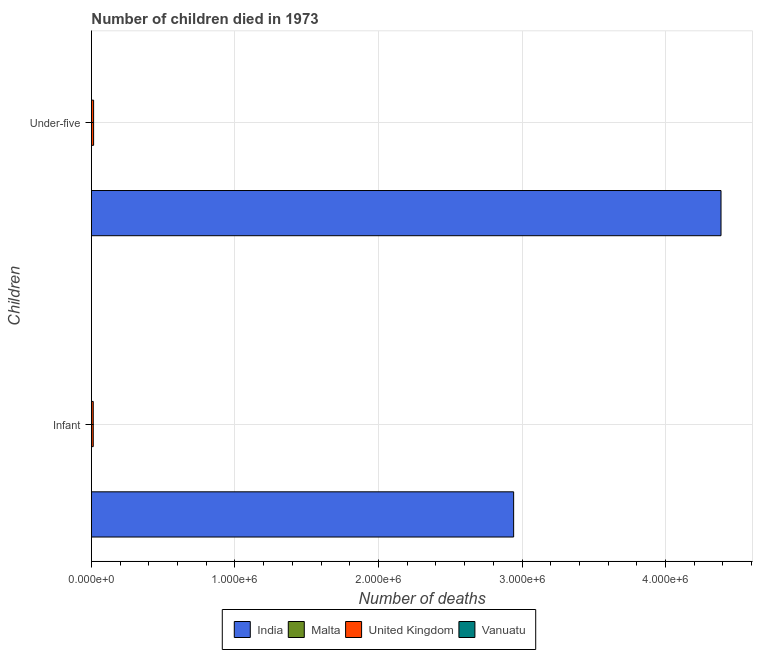How many different coloured bars are there?
Provide a succinct answer. 4. How many groups of bars are there?
Make the answer very short. 2. Are the number of bars on each tick of the Y-axis equal?
Make the answer very short. Yes. How many bars are there on the 2nd tick from the top?
Offer a very short reply. 4. How many bars are there on the 1st tick from the bottom?
Ensure brevity in your answer.  4. What is the label of the 2nd group of bars from the top?
Make the answer very short. Infant. What is the number of under-five deaths in India?
Provide a succinct answer. 4.39e+06. Across all countries, what is the maximum number of under-five deaths?
Make the answer very short. 4.39e+06. Across all countries, what is the minimum number of infant deaths?
Provide a short and direct response. 112. In which country was the number of infant deaths minimum?
Offer a terse response. Malta. What is the total number of infant deaths in the graph?
Offer a terse response. 2.95e+06. What is the difference between the number of under-five deaths in Malta and that in India?
Provide a short and direct response. -4.39e+06. What is the difference between the number of infant deaths in India and the number of under-five deaths in Malta?
Make the answer very short. 2.94e+06. What is the average number of infant deaths per country?
Your answer should be very brief. 7.39e+05. What is the difference between the number of under-five deaths and number of infant deaths in Malta?
Offer a terse response. 12. In how many countries, is the number of infant deaths greater than 1800000 ?
Provide a succinct answer. 1. What is the ratio of the number of under-five deaths in India to that in Malta?
Keep it short and to the point. 3.54e+04. Is the number of infant deaths in Vanuatu less than that in United Kingdom?
Your answer should be compact. Yes. How many bars are there?
Give a very brief answer. 8. Does the graph contain grids?
Provide a succinct answer. Yes. How many legend labels are there?
Provide a succinct answer. 4. How are the legend labels stacked?
Keep it short and to the point. Horizontal. What is the title of the graph?
Make the answer very short. Number of children died in 1973. Does "Guinea-Bissau" appear as one of the legend labels in the graph?
Give a very brief answer. No. What is the label or title of the X-axis?
Your response must be concise. Number of deaths. What is the label or title of the Y-axis?
Your answer should be compact. Children. What is the Number of deaths in India in Infant?
Offer a very short reply. 2.94e+06. What is the Number of deaths of Malta in Infant?
Keep it short and to the point. 112. What is the Number of deaths in United Kingdom in Infant?
Provide a short and direct response. 1.27e+04. What is the Number of deaths in Vanuatu in Infant?
Offer a terse response. 252. What is the Number of deaths of India in Under-five?
Give a very brief answer. 4.39e+06. What is the Number of deaths in Malta in Under-five?
Provide a short and direct response. 124. What is the Number of deaths of United Kingdom in Under-five?
Provide a succinct answer. 1.52e+04. What is the Number of deaths in Vanuatu in Under-five?
Your answer should be very brief. 343. Across all Children, what is the maximum Number of deaths in India?
Offer a terse response. 4.39e+06. Across all Children, what is the maximum Number of deaths in Malta?
Your response must be concise. 124. Across all Children, what is the maximum Number of deaths in United Kingdom?
Provide a short and direct response. 1.52e+04. Across all Children, what is the maximum Number of deaths of Vanuatu?
Your answer should be compact. 343. Across all Children, what is the minimum Number of deaths in India?
Offer a very short reply. 2.94e+06. Across all Children, what is the minimum Number of deaths of Malta?
Make the answer very short. 112. Across all Children, what is the minimum Number of deaths in United Kingdom?
Give a very brief answer. 1.27e+04. Across all Children, what is the minimum Number of deaths in Vanuatu?
Your answer should be very brief. 252. What is the total Number of deaths of India in the graph?
Provide a succinct answer. 7.33e+06. What is the total Number of deaths in Malta in the graph?
Give a very brief answer. 236. What is the total Number of deaths of United Kingdom in the graph?
Ensure brevity in your answer.  2.79e+04. What is the total Number of deaths in Vanuatu in the graph?
Offer a very short reply. 595. What is the difference between the Number of deaths in India in Infant and that in Under-five?
Keep it short and to the point. -1.44e+06. What is the difference between the Number of deaths in Malta in Infant and that in Under-five?
Your answer should be compact. -12. What is the difference between the Number of deaths in United Kingdom in Infant and that in Under-five?
Provide a succinct answer. -2455. What is the difference between the Number of deaths of Vanuatu in Infant and that in Under-five?
Provide a succinct answer. -91. What is the difference between the Number of deaths in India in Infant and the Number of deaths in Malta in Under-five?
Your answer should be very brief. 2.94e+06. What is the difference between the Number of deaths in India in Infant and the Number of deaths in United Kingdom in Under-five?
Ensure brevity in your answer.  2.93e+06. What is the difference between the Number of deaths of India in Infant and the Number of deaths of Vanuatu in Under-five?
Offer a terse response. 2.94e+06. What is the difference between the Number of deaths in Malta in Infant and the Number of deaths in United Kingdom in Under-five?
Give a very brief answer. -1.51e+04. What is the difference between the Number of deaths in Malta in Infant and the Number of deaths in Vanuatu in Under-five?
Provide a succinct answer. -231. What is the difference between the Number of deaths in United Kingdom in Infant and the Number of deaths in Vanuatu in Under-five?
Offer a very short reply. 1.24e+04. What is the average Number of deaths in India per Children?
Your answer should be compact. 3.66e+06. What is the average Number of deaths in Malta per Children?
Give a very brief answer. 118. What is the average Number of deaths in United Kingdom per Children?
Keep it short and to the point. 1.40e+04. What is the average Number of deaths of Vanuatu per Children?
Offer a terse response. 297.5. What is the difference between the Number of deaths of India and Number of deaths of Malta in Infant?
Offer a terse response. 2.94e+06. What is the difference between the Number of deaths of India and Number of deaths of United Kingdom in Infant?
Give a very brief answer. 2.93e+06. What is the difference between the Number of deaths of India and Number of deaths of Vanuatu in Infant?
Ensure brevity in your answer.  2.94e+06. What is the difference between the Number of deaths in Malta and Number of deaths in United Kingdom in Infant?
Give a very brief answer. -1.26e+04. What is the difference between the Number of deaths in Malta and Number of deaths in Vanuatu in Infant?
Provide a short and direct response. -140. What is the difference between the Number of deaths of United Kingdom and Number of deaths of Vanuatu in Infant?
Ensure brevity in your answer.  1.25e+04. What is the difference between the Number of deaths of India and Number of deaths of Malta in Under-five?
Offer a terse response. 4.39e+06. What is the difference between the Number of deaths in India and Number of deaths in United Kingdom in Under-five?
Make the answer very short. 4.37e+06. What is the difference between the Number of deaths in India and Number of deaths in Vanuatu in Under-five?
Offer a terse response. 4.39e+06. What is the difference between the Number of deaths of Malta and Number of deaths of United Kingdom in Under-five?
Offer a terse response. -1.51e+04. What is the difference between the Number of deaths in Malta and Number of deaths in Vanuatu in Under-five?
Offer a very short reply. -219. What is the difference between the Number of deaths in United Kingdom and Number of deaths in Vanuatu in Under-five?
Provide a succinct answer. 1.48e+04. What is the ratio of the Number of deaths of India in Infant to that in Under-five?
Provide a succinct answer. 0.67. What is the ratio of the Number of deaths in Malta in Infant to that in Under-five?
Your answer should be very brief. 0.9. What is the ratio of the Number of deaths of United Kingdom in Infant to that in Under-five?
Provide a succinct answer. 0.84. What is the ratio of the Number of deaths of Vanuatu in Infant to that in Under-five?
Give a very brief answer. 0.73. What is the difference between the highest and the second highest Number of deaths of India?
Your answer should be very brief. 1.44e+06. What is the difference between the highest and the second highest Number of deaths in Malta?
Provide a succinct answer. 12. What is the difference between the highest and the second highest Number of deaths in United Kingdom?
Give a very brief answer. 2455. What is the difference between the highest and the second highest Number of deaths in Vanuatu?
Provide a short and direct response. 91. What is the difference between the highest and the lowest Number of deaths of India?
Your response must be concise. 1.44e+06. What is the difference between the highest and the lowest Number of deaths in United Kingdom?
Offer a very short reply. 2455. What is the difference between the highest and the lowest Number of deaths in Vanuatu?
Give a very brief answer. 91. 